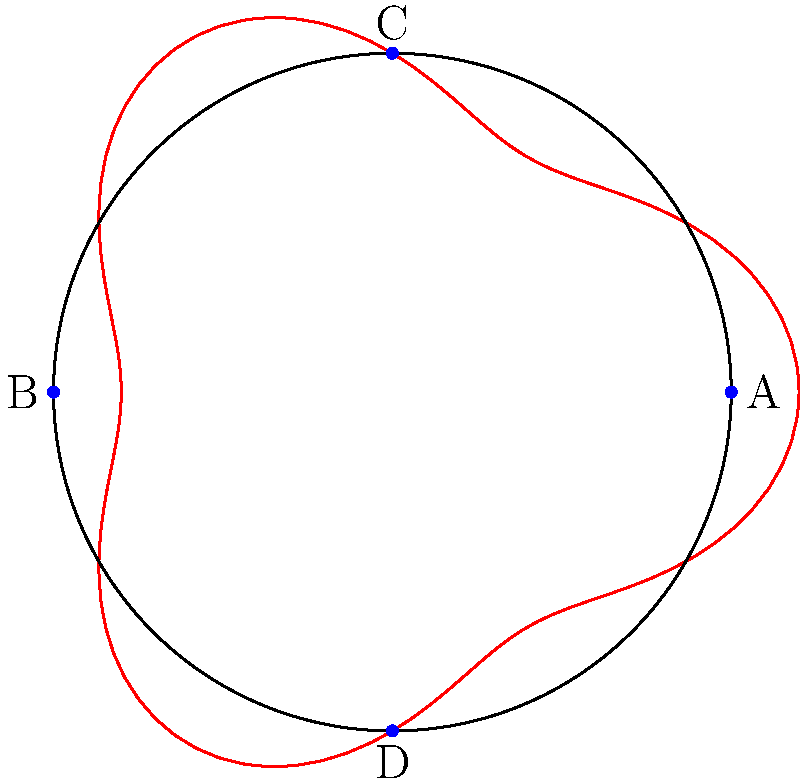In a circular room with radius 5 meters, four listening devices need to be placed for optimal coverage. The devices are placed at points A, B, C, and D as shown in the diagram. The red curve represents the path of a moving target, described by the polar equation $r = 5 + \cos(3\theta)$. At which point(s) will the target be closest to a listening device, and what is this minimum distance? To solve this problem, we need to follow these steps:

1) The listening devices are placed at (5,0), (-5,0), (0,5), and (0,-5) in Cartesian coordinates.

2) The target's path is given by $r = 5 + \cos(3\theta)$ in polar coordinates.

3) To find the minimum distance, we need to convert the polar equation to Cartesian form:
   $x = r\cos(\theta) = (5 + \cos(3\theta))\cos(\theta)$
   $y = r\sin(\theta) = (5 + \cos(3\theta))\sin(\theta)$

4) The distance $d$ from any point $(x,y)$ on the path to a device at $(a,b)$ is given by:
   $d = \sqrt{(x-a)^2 + (y-b)^2}$

5) For each device, we need to minimize this distance function with respect to $\theta$.

6) Due to the symmetry of the situation, we only need to check one device, say A at (5,0).

7) The distance function for A is:
   $d_A = \sqrt{((5 + \cos(3\theta))\cos(\theta) - 5)^2 + ((5 + \cos(3\theta))\sin(\theta))^2}$

8) Minimizing this function analytically is complex, so we use numerical methods.

9) The minimum occurs at $\theta = 0$, where $r = 6$.

10) At this point, the distance to A is:
    $d_A = \sqrt{(6 - 5)^2 + 0^2} = 1$

11) Due to symmetry, the same minimum distance occurs at B when $\theta = \pi$, at C when $\theta = \pi/2$, and at D when $\theta = 3\pi/2$.

Therefore, the target will be closest to a listening device at four points, corresponding to $\theta = 0, \pi/2, \pi, 3\pi/2$, and the minimum distance at each of these points is 1 meter.
Answer: Points A, B, C, D; 1 meter 